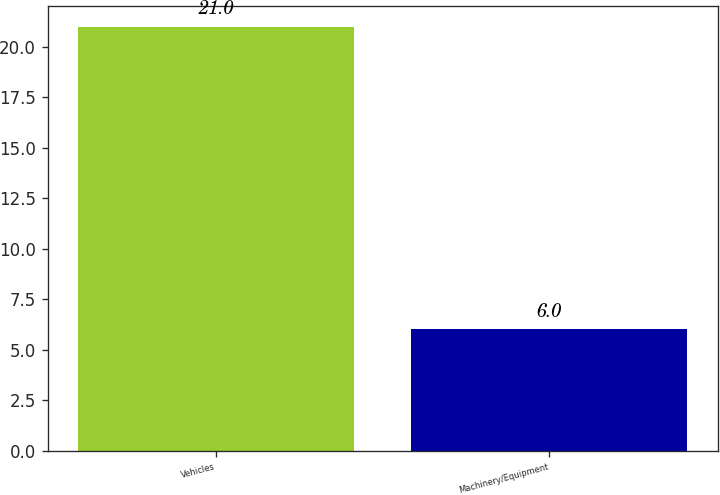<chart> <loc_0><loc_0><loc_500><loc_500><bar_chart><fcel>Vehicles<fcel>Machinery/Equipment<nl><fcel>21<fcel>6<nl></chart> 